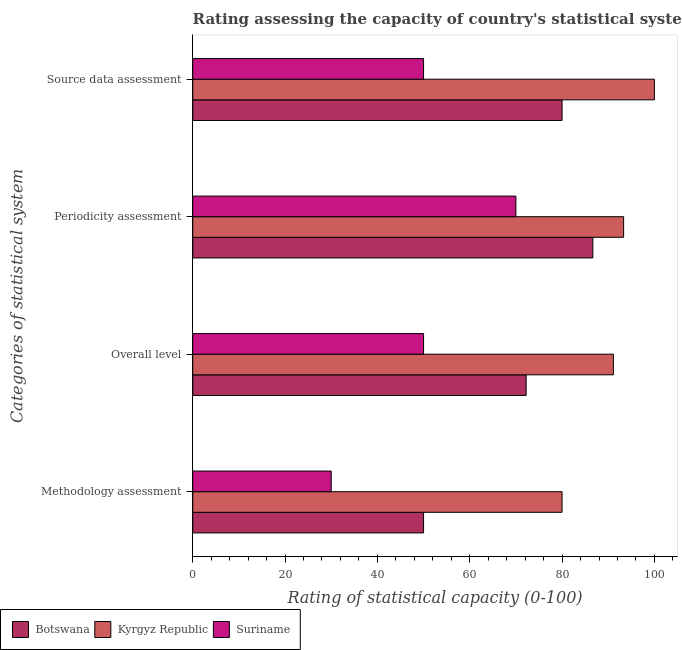Are the number of bars per tick equal to the number of legend labels?
Keep it short and to the point. Yes. Are the number of bars on each tick of the Y-axis equal?
Your answer should be very brief. Yes. How many bars are there on the 4th tick from the top?
Keep it short and to the point. 3. How many bars are there on the 2nd tick from the bottom?
Keep it short and to the point. 3. What is the label of the 4th group of bars from the top?
Give a very brief answer. Methodology assessment. What is the overall level rating in Kyrgyz Republic?
Provide a short and direct response. 91.11. Across all countries, what is the maximum overall level rating?
Keep it short and to the point. 91.11. In which country was the methodology assessment rating maximum?
Ensure brevity in your answer.  Kyrgyz Republic. In which country was the periodicity assessment rating minimum?
Ensure brevity in your answer.  Suriname. What is the total source data assessment rating in the graph?
Offer a very short reply. 230. What is the difference between the periodicity assessment rating in Botswana and that in Kyrgyz Republic?
Provide a succinct answer. -6.67. What is the difference between the overall level rating in Suriname and the periodicity assessment rating in Botswana?
Give a very brief answer. -36.67. What is the average methodology assessment rating per country?
Offer a terse response. 53.33. What is the difference between the overall level rating and periodicity assessment rating in Botswana?
Provide a succinct answer. -14.44. In how many countries, is the source data assessment rating greater than 60 ?
Keep it short and to the point. 2. What is the ratio of the overall level rating in Suriname to that in Kyrgyz Republic?
Provide a succinct answer. 0.55. Is the source data assessment rating in Kyrgyz Republic less than that in Botswana?
Offer a terse response. No. Is the difference between the source data assessment rating in Suriname and Botswana greater than the difference between the methodology assessment rating in Suriname and Botswana?
Give a very brief answer. No. What is the difference between the highest and the second highest overall level rating?
Offer a very short reply. 18.89. Is it the case that in every country, the sum of the source data assessment rating and methodology assessment rating is greater than the sum of periodicity assessment rating and overall level rating?
Give a very brief answer. No. What does the 1st bar from the top in Methodology assessment represents?
Provide a short and direct response. Suriname. What does the 3rd bar from the bottom in Source data assessment represents?
Provide a short and direct response. Suriname. Is it the case that in every country, the sum of the methodology assessment rating and overall level rating is greater than the periodicity assessment rating?
Your answer should be compact. Yes. How many countries are there in the graph?
Ensure brevity in your answer.  3. Does the graph contain grids?
Your answer should be very brief. No. Where does the legend appear in the graph?
Offer a terse response. Bottom left. How many legend labels are there?
Provide a short and direct response. 3. What is the title of the graph?
Your answer should be very brief. Rating assessing the capacity of country's statistical systems as per the survey of 2005 . What is the label or title of the X-axis?
Ensure brevity in your answer.  Rating of statistical capacity (0-100). What is the label or title of the Y-axis?
Offer a very short reply. Categories of statistical system. What is the Rating of statistical capacity (0-100) of Botswana in Overall level?
Offer a very short reply. 72.22. What is the Rating of statistical capacity (0-100) in Kyrgyz Republic in Overall level?
Make the answer very short. 91.11. What is the Rating of statistical capacity (0-100) of Botswana in Periodicity assessment?
Keep it short and to the point. 86.67. What is the Rating of statistical capacity (0-100) of Kyrgyz Republic in Periodicity assessment?
Give a very brief answer. 93.33. What is the Rating of statistical capacity (0-100) of Botswana in Source data assessment?
Your answer should be compact. 80. What is the Rating of statistical capacity (0-100) in Kyrgyz Republic in Source data assessment?
Your response must be concise. 100. Across all Categories of statistical system, what is the maximum Rating of statistical capacity (0-100) in Botswana?
Keep it short and to the point. 86.67. Across all Categories of statistical system, what is the minimum Rating of statistical capacity (0-100) of Suriname?
Ensure brevity in your answer.  30. What is the total Rating of statistical capacity (0-100) in Botswana in the graph?
Offer a very short reply. 288.89. What is the total Rating of statistical capacity (0-100) in Kyrgyz Republic in the graph?
Make the answer very short. 364.44. What is the difference between the Rating of statistical capacity (0-100) in Botswana in Methodology assessment and that in Overall level?
Your response must be concise. -22.22. What is the difference between the Rating of statistical capacity (0-100) in Kyrgyz Republic in Methodology assessment and that in Overall level?
Give a very brief answer. -11.11. What is the difference between the Rating of statistical capacity (0-100) in Botswana in Methodology assessment and that in Periodicity assessment?
Give a very brief answer. -36.67. What is the difference between the Rating of statistical capacity (0-100) in Kyrgyz Republic in Methodology assessment and that in Periodicity assessment?
Ensure brevity in your answer.  -13.33. What is the difference between the Rating of statistical capacity (0-100) in Botswana in Methodology assessment and that in Source data assessment?
Your response must be concise. -30. What is the difference between the Rating of statistical capacity (0-100) of Botswana in Overall level and that in Periodicity assessment?
Offer a terse response. -14.44. What is the difference between the Rating of statistical capacity (0-100) of Kyrgyz Republic in Overall level and that in Periodicity assessment?
Offer a terse response. -2.22. What is the difference between the Rating of statistical capacity (0-100) in Botswana in Overall level and that in Source data assessment?
Your answer should be very brief. -7.78. What is the difference between the Rating of statistical capacity (0-100) of Kyrgyz Republic in Overall level and that in Source data assessment?
Ensure brevity in your answer.  -8.89. What is the difference between the Rating of statistical capacity (0-100) of Suriname in Overall level and that in Source data assessment?
Offer a very short reply. 0. What is the difference between the Rating of statistical capacity (0-100) of Kyrgyz Republic in Periodicity assessment and that in Source data assessment?
Ensure brevity in your answer.  -6.67. What is the difference between the Rating of statistical capacity (0-100) of Botswana in Methodology assessment and the Rating of statistical capacity (0-100) of Kyrgyz Republic in Overall level?
Your answer should be very brief. -41.11. What is the difference between the Rating of statistical capacity (0-100) of Botswana in Methodology assessment and the Rating of statistical capacity (0-100) of Suriname in Overall level?
Your answer should be compact. 0. What is the difference between the Rating of statistical capacity (0-100) in Kyrgyz Republic in Methodology assessment and the Rating of statistical capacity (0-100) in Suriname in Overall level?
Make the answer very short. 30. What is the difference between the Rating of statistical capacity (0-100) in Botswana in Methodology assessment and the Rating of statistical capacity (0-100) in Kyrgyz Republic in Periodicity assessment?
Offer a terse response. -43.33. What is the difference between the Rating of statistical capacity (0-100) in Botswana in Methodology assessment and the Rating of statistical capacity (0-100) in Suriname in Periodicity assessment?
Make the answer very short. -20. What is the difference between the Rating of statistical capacity (0-100) in Kyrgyz Republic in Methodology assessment and the Rating of statistical capacity (0-100) in Suriname in Periodicity assessment?
Give a very brief answer. 10. What is the difference between the Rating of statistical capacity (0-100) in Botswana in Methodology assessment and the Rating of statistical capacity (0-100) in Kyrgyz Republic in Source data assessment?
Provide a short and direct response. -50. What is the difference between the Rating of statistical capacity (0-100) of Botswana in Methodology assessment and the Rating of statistical capacity (0-100) of Suriname in Source data assessment?
Your answer should be very brief. 0. What is the difference between the Rating of statistical capacity (0-100) of Kyrgyz Republic in Methodology assessment and the Rating of statistical capacity (0-100) of Suriname in Source data assessment?
Give a very brief answer. 30. What is the difference between the Rating of statistical capacity (0-100) of Botswana in Overall level and the Rating of statistical capacity (0-100) of Kyrgyz Republic in Periodicity assessment?
Provide a succinct answer. -21.11. What is the difference between the Rating of statistical capacity (0-100) in Botswana in Overall level and the Rating of statistical capacity (0-100) in Suriname in Periodicity assessment?
Provide a short and direct response. 2.22. What is the difference between the Rating of statistical capacity (0-100) in Kyrgyz Republic in Overall level and the Rating of statistical capacity (0-100) in Suriname in Periodicity assessment?
Offer a very short reply. 21.11. What is the difference between the Rating of statistical capacity (0-100) of Botswana in Overall level and the Rating of statistical capacity (0-100) of Kyrgyz Republic in Source data assessment?
Make the answer very short. -27.78. What is the difference between the Rating of statistical capacity (0-100) of Botswana in Overall level and the Rating of statistical capacity (0-100) of Suriname in Source data assessment?
Your response must be concise. 22.22. What is the difference between the Rating of statistical capacity (0-100) of Kyrgyz Republic in Overall level and the Rating of statistical capacity (0-100) of Suriname in Source data assessment?
Your answer should be compact. 41.11. What is the difference between the Rating of statistical capacity (0-100) in Botswana in Periodicity assessment and the Rating of statistical capacity (0-100) in Kyrgyz Republic in Source data assessment?
Provide a succinct answer. -13.33. What is the difference between the Rating of statistical capacity (0-100) in Botswana in Periodicity assessment and the Rating of statistical capacity (0-100) in Suriname in Source data assessment?
Provide a succinct answer. 36.67. What is the difference between the Rating of statistical capacity (0-100) of Kyrgyz Republic in Periodicity assessment and the Rating of statistical capacity (0-100) of Suriname in Source data assessment?
Offer a terse response. 43.33. What is the average Rating of statistical capacity (0-100) in Botswana per Categories of statistical system?
Provide a short and direct response. 72.22. What is the average Rating of statistical capacity (0-100) in Kyrgyz Republic per Categories of statistical system?
Give a very brief answer. 91.11. What is the average Rating of statistical capacity (0-100) in Suriname per Categories of statistical system?
Offer a terse response. 50. What is the difference between the Rating of statistical capacity (0-100) in Botswana and Rating of statistical capacity (0-100) in Kyrgyz Republic in Methodology assessment?
Make the answer very short. -30. What is the difference between the Rating of statistical capacity (0-100) of Botswana and Rating of statistical capacity (0-100) of Suriname in Methodology assessment?
Offer a very short reply. 20. What is the difference between the Rating of statistical capacity (0-100) of Kyrgyz Republic and Rating of statistical capacity (0-100) of Suriname in Methodology assessment?
Your answer should be compact. 50. What is the difference between the Rating of statistical capacity (0-100) of Botswana and Rating of statistical capacity (0-100) of Kyrgyz Republic in Overall level?
Provide a succinct answer. -18.89. What is the difference between the Rating of statistical capacity (0-100) in Botswana and Rating of statistical capacity (0-100) in Suriname in Overall level?
Your response must be concise. 22.22. What is the difference between the Rating of statistical capacity (0-100) of Kyrgyz Republic and Rating of statistical capacity (0-100) of Suriname in Overall level?
Offer a very short reply. 41.11. What is the difference between the Rating of statistical capacity (0-100) in Botswana and Rating of statistical capacity (0-100) in Kyrgyz Republic in Periodicity assessment?
Your answer should be very brief. -6.67. What is the difference between the Rating of statistical capacity (0-100) in Botswana and Rating of statistical capacity (0-100) in Suriname in Periodicity assessment?
Your answer should be compact. 16.67. What is the difference between the Rating of statistical capacity (0-100) in Kyrgyz Republic and Rating of statistical capacity (0-100) in Suriname in Periodicity assessment?
Give a very brief answer. 23.33. What is the ratio of the Rating of statistical capacity (0-100) of Botswana in Methodology assessment to that in Overall level?
Your answer should be compact. 0.69. What is the ratio of the Rating of statistical capacity (0-100) of Kyrgyz Republic in Methodology assessment to that in Overall level?
Provide a short and direct response. 0.88. What is the ratio of the Rating of statistical capacity (0-100) of Botswana in Methodology assessment to that in Periodicity assessment?
Give a very brief answer. 0.58. What is the ratio of the Rating of statistical capacity (0-100) in Suriname in Methodology assessment to that in Periodicity assessment?
Your answer should be compact. 0.43. What is the ratio of the Rating of statistical capacity (0-100) of Botswana in Methodology assessment to that in Source data assessment?
Provide a succinct answer. 0.62. What is the ratio of the Rating of statistical capacity (0-100) of Suriname in Methodology assessment to that in Source data assessment?
Provide a succinct answer. 0.6. What is the ratio of the Rating of statistical capacity (0-100) of Botswana in Overall level to that in Periodicity assessment?
Make the answer very short. 0.83. What is the ratio of the Rating of statistical capacity (0-100) of Kyrgyz Republic in Overall level to that in Periodicity assessment?
Keep it short and to the point. 0.98. What is the ratio of the Rating of statistical capacity (0-100) in Botswana in Overall level to that in Source data assessment?
Your answer should be compact. 0.9. What is the ratio of the Rating of statistical capacity (0-100) in Kyrgyz Republic in Overall level to that in Source data assessment?
Give a very brief answer. 0.91. What is the ratio of the Rating of statistical capacity (0-100) in Botswana in Periodicity assessment to that in Source data assessment?
Your answer should be very brief. 1.08. What is the ratio of the Rating of statistical capacity (0-100) in Kyrgyz Republic in Periodicity assessment to that in Source data assessment?
Your response must be concise. 0.93. What is the ratio of the Rating of statistical capacity (0-100) of Suriname in Periodicity assessment to that in Source data assessment?
Your response must be concise. 1.4. What is the difference between the highest and the second highest Rating of statistical capacity (0-100) of Botswana?
Make the answer very short. 6.67. What is the difference between the highest and the second highest Rating of statistical capacity (0-100) of Suriname?
Your answer should be compact. 20. What is the difference between the highest and the lowest Rating of statistical capacity (0-100) in Botswana?
Your response must be concise. 36.67. 